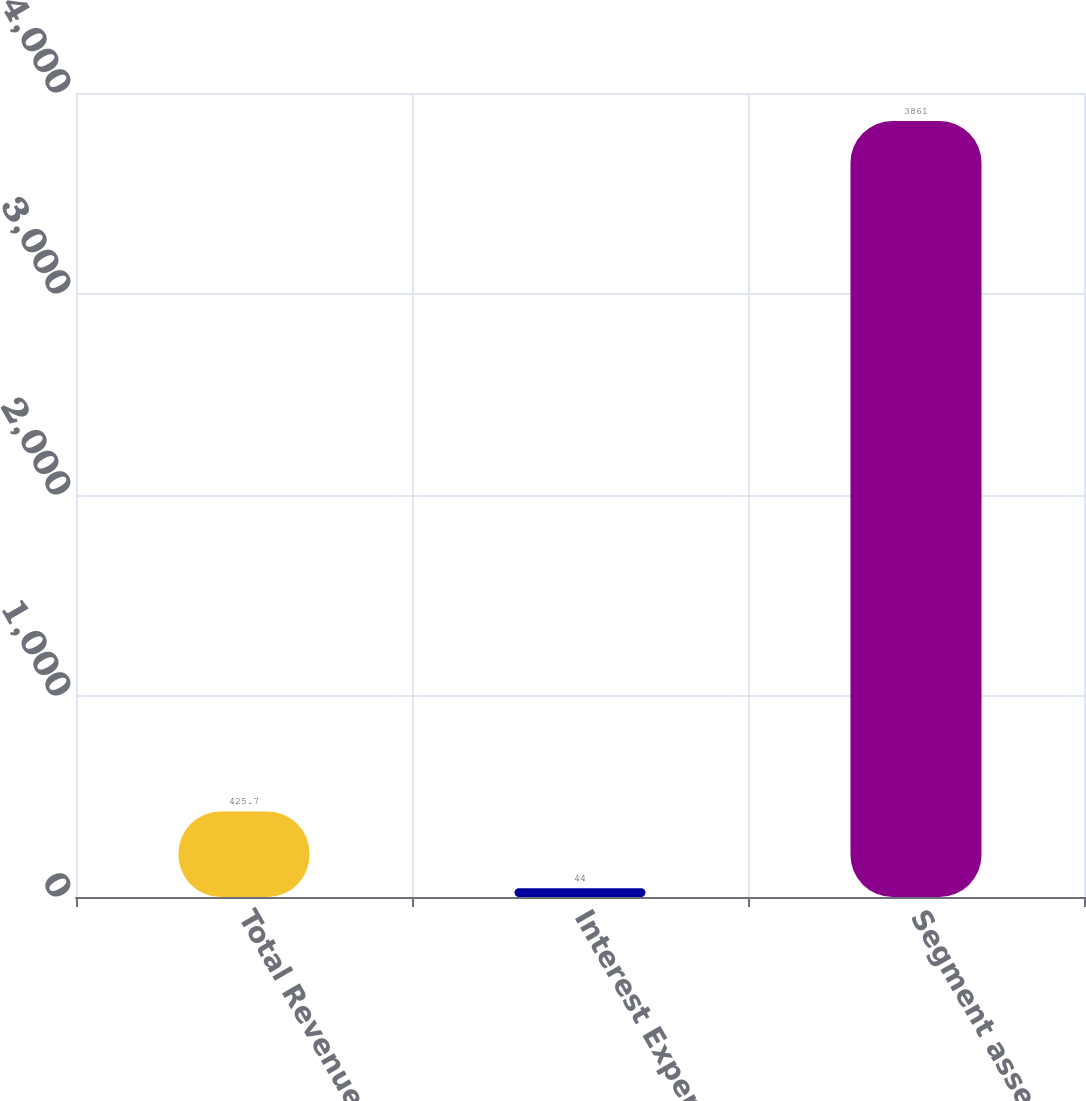Convert chart to OTSL. <chart><loc_0><loc_0><loc_500><loc_500><bar_chart><fcel>Total Revenues<fcel>Interest Expense<fcel>Segment assets (f)<nl><fcel>425.7<fcel>44<fcel>3861<nl></chart> 